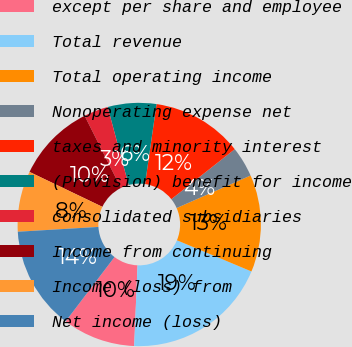Convert chart to OTSL. <chart><loc_0><loc_0><loc_500><loc_500><pie_chart><fcel>except per share and employee<fcel>Total revenue<fcel>Total operating income<fcel>Nonoperating expense net<fcel>taxes and minority interest<fcel>(Provision) benefit for income<fcel>consolidated subsidiaries<fcel>Income from continuing<fcel>Income (loss) from<fcel>Net income (loss)<nl><fcel>9.68%<fcel>19.35%<fcel>12.9%<fcel>4.03%<fcel>12.1%<fcel>6.45%<fcel>3.23%<fcel>10.48%<fcel>8.06%<fcel>13.71%<nl></chart> 